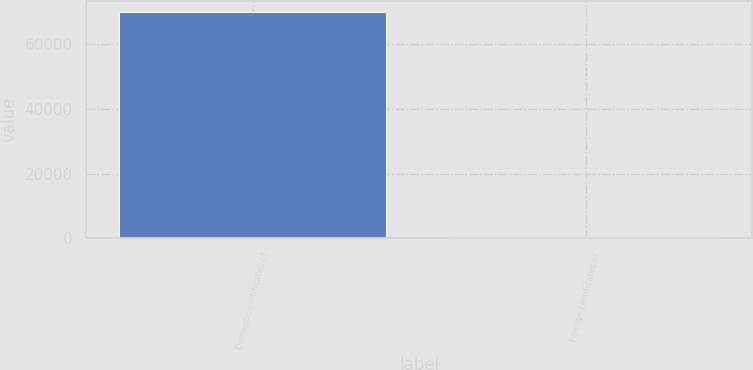Convert chart. <chart><loc_0><loc_0><loc_500><loc_500><bar_chart><fcel>Domestic certificates of<fcel>Foreign certificates of<nl><fcel>69913<fcel>486<nl></chart> 